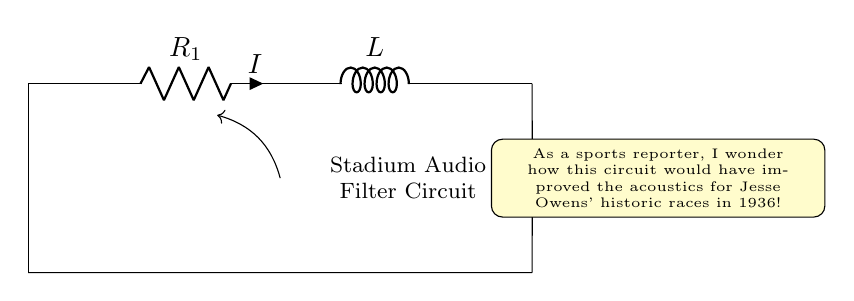What type of circuit is shown? The circuit is an RLC audio filter circuit, which includes a resistor, inductor, and capacitor arranged to filter audio signals effectively.
Answer: RLC audio filter What is the function of the resistor in this circuit? The resistor limits the current flowing through the circuit and can help define the circuit's overall impedance, impacting the filter's response characteristics.
Answer: Limits current What is the role of the inductor in the audio filter circuit? The inductor stores energy in a magnetic field when current flows through it, providing inductive reactance that influences the frequency response of the circuit.
Answer: Inductive reactance How does the capacitor affect the circuit behavior? The capacitor stores electrical energy temporarily and introduces capacitive reactance, which varies with frequency, thus playing a key role in determining the filter characteristics.
Answer: Capacitive reactance What happens to high-frequency signals in this circuit? The circuit is designed to filter high-frequency signals effectively, allowing lower frequencies to pass while attenuating higher frequencies based on the values of R, L, and C.
Answer: Attenuated What is the significance of using an RLC circuit for audio filtration? RLC circuits can create specific filtering effects (like low-pass, high-pass, or band-pass) based on the values of the components, thus enhancing audio quality by reducing unwanted frequencies.
Answer: Enhances audio quality 